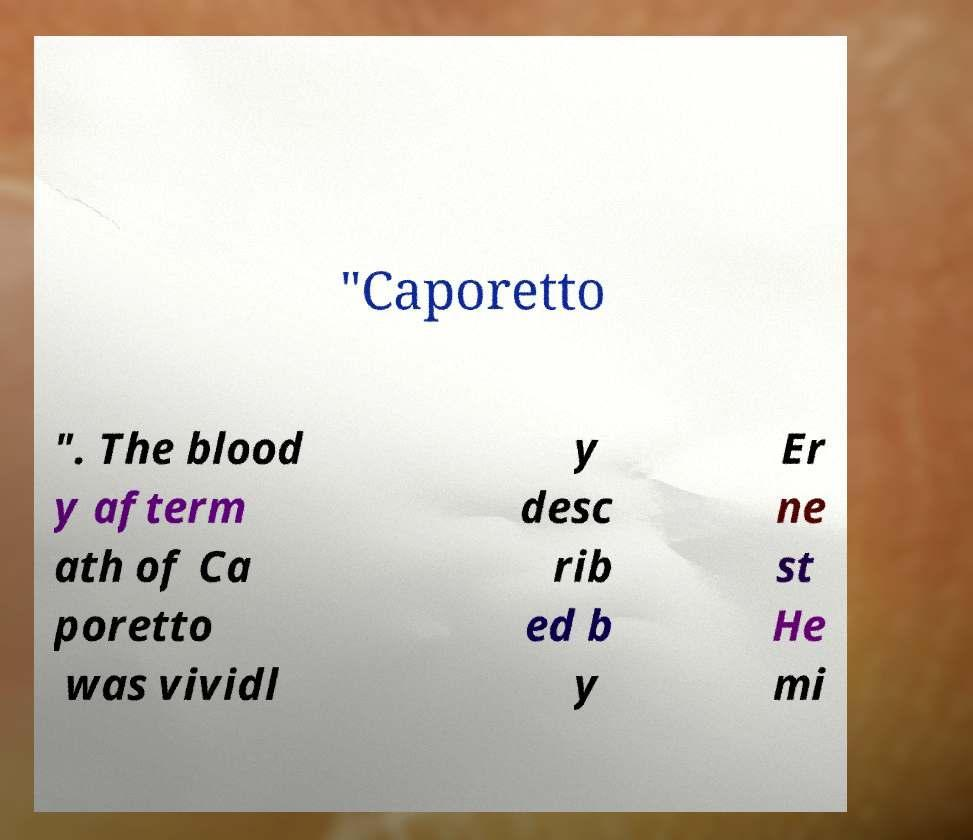What messages or text are displayed in this image? I need them in a readable, typed format. "Caporetto ". The blood y afterm ath of Ca poretto was vividl y desc rib ed b y Er ne st He mi 